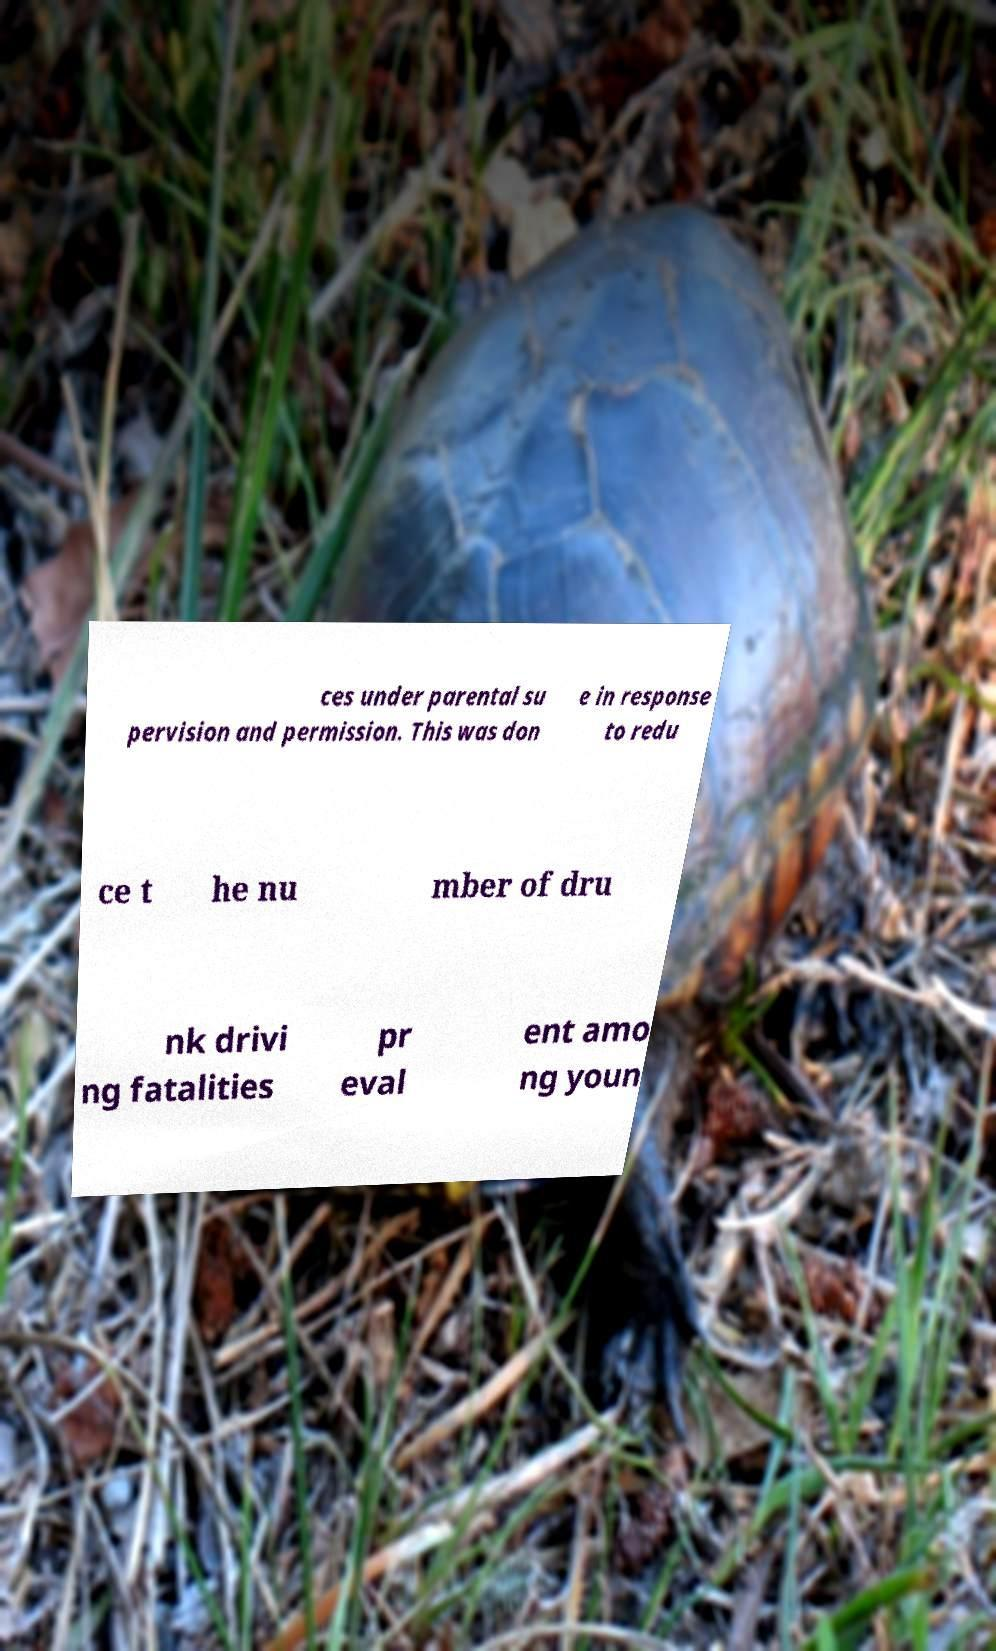Please read and relay the text visible in this image. What does it say? ces under parental su pervision and permission. This was don e in response to redu ce t he nu mber of dru nk drivi ng fatalities pr eval ent amo ng youn 